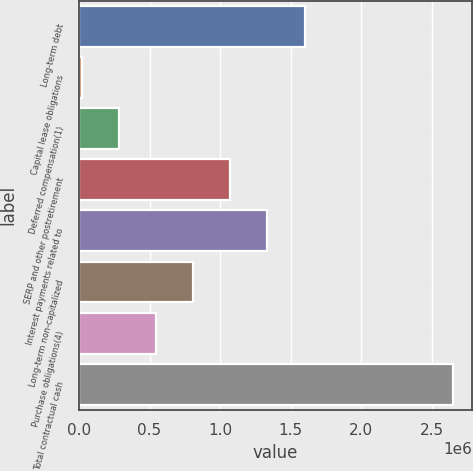<chart> <loc_0><loc_0><loc_500><loc_500><bar_chart><fcel>Long-term debt<fcel>Capital lease obligations<fcel>Deferred compensation(1)<fcel>SERP and other postretirement<fcel>Interest payments related to<fcel>Long-term non-capitalized<fcel>Purchase obligations(4)<fcel>Total contractual cash<nl><fcel>1.59795e+06<fcel>21319<fcel>284091<fcel>1.07241e+06<fcel>1.33518e+06<fcel>809634<fcel>546862<fcel>2.64904e+06<nl></chart> 